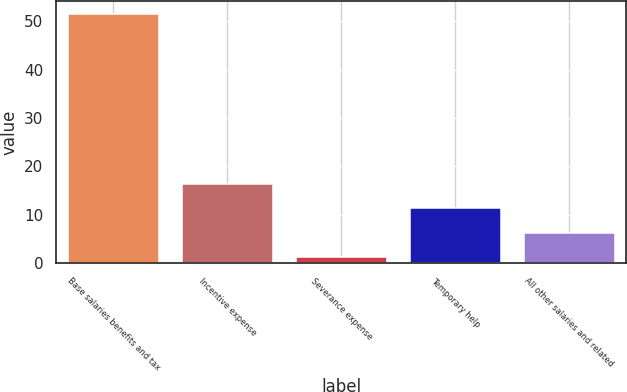<chart> <loc_0><loc_0><loc_500><loc_500><bar_chart><fcel>Base salaries benefits and tax<fcel>Incentive expense<fcel>Severance expense<fcel>Temporary help<fcel>All other salaries and related<nl><fcel>51.6<fcel>16.39<fcel>1.3<fcel>11.36<fcel>6.33<nl></chart> 